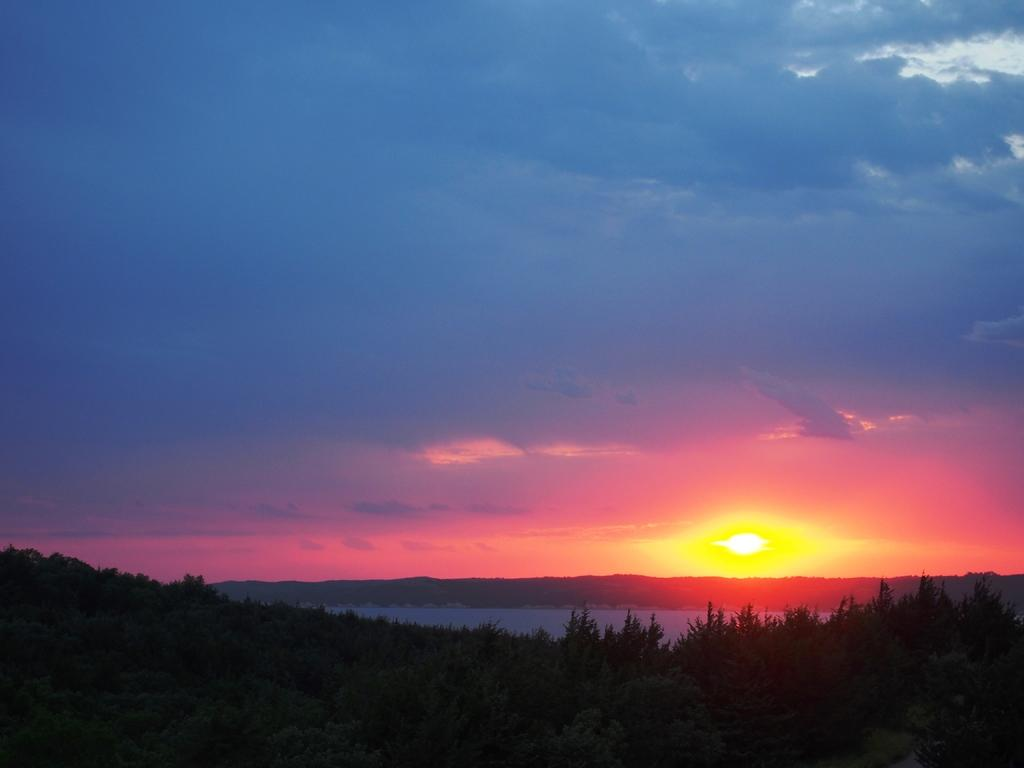What is located at the bottom of the image? There are trees, water, and hills at the bottom of the image. What can be seen in the background of the image? There is a sky visible in the background of the image. What is the condition of the sky in the image? The sky has clouds and the sun is visible in it. How many cats can be seen biting the trees in the image? There are no cats present in the image, and therefore no such activity can be observed. 